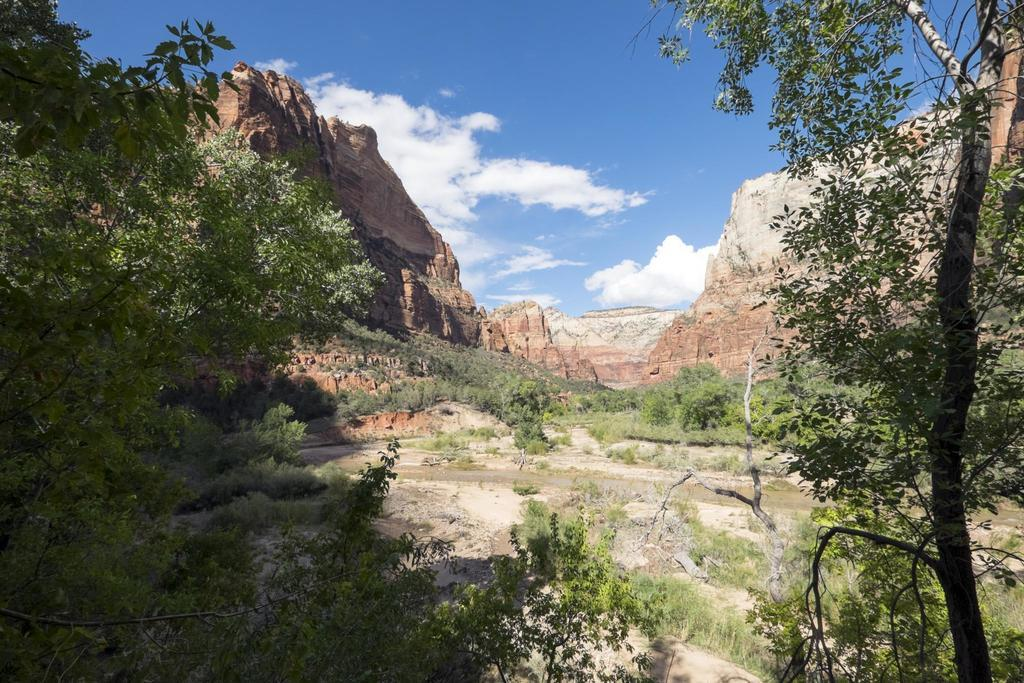What type of vegetation can be seen in the image? There are trees in the image. What is the ground covered with in the image? There is grass in the image. What type of natural feature can be seen in the image? There are rocks in the image. What is the condition of the sky in the image? The sky is cloudy in the image. Can you tell me how many berries are growing on the trees in the image? There is no mention of berries in the image; it only features trees, grass, rocks, and a cloudy sky. What type of notebook is being used to take notes about the image? There is no notebook present in the image, nor is there any indication that someone is taking notes about the image. 